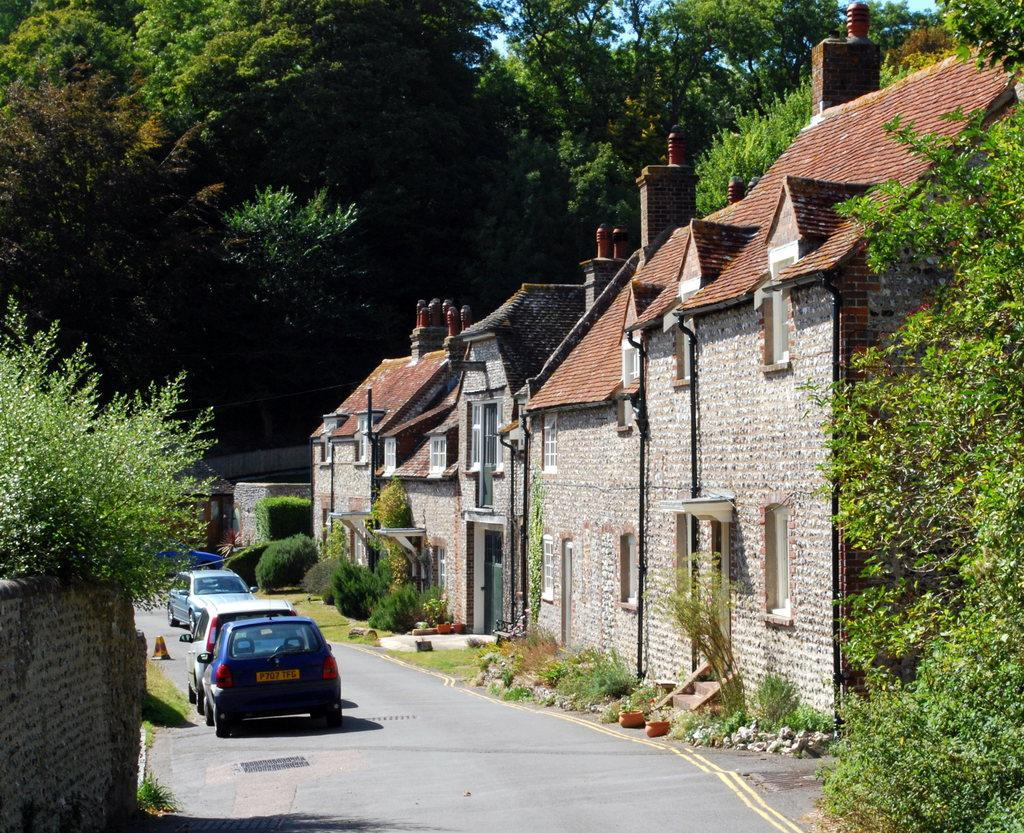What type of structures can be seen in the image? There are houses in the image. What natural elements are present in the image? There are many trees and plants in the image. What type of transportation is visible in the image? There are vehicles on the road in the image. What can be seen in the sky in the image? The sky is visible in the image. What color is the mom's sweater in the image? There is no mom or sweater present in the image. 